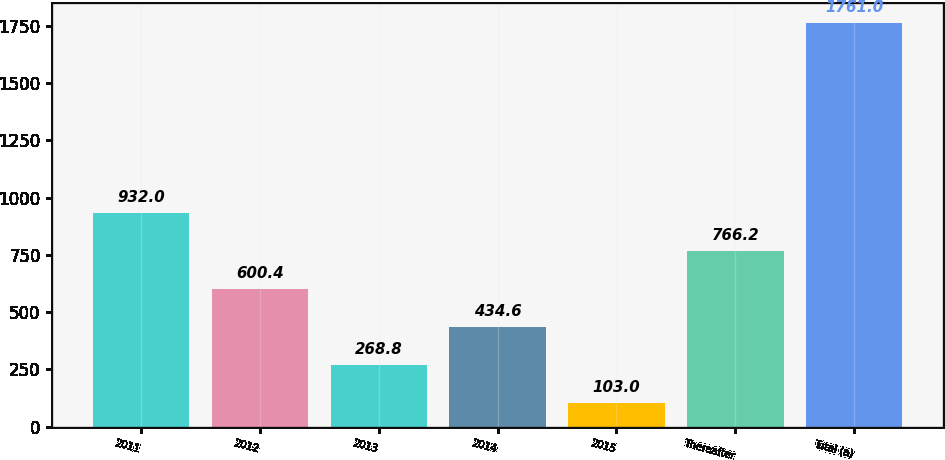Convert chart to OTSL. <chart><loc_0><loc_0><loc_500><loc_500><bar_chart><fcel>2011<fcel>2012<fcel>2013<fcel>2014<fcel>2015<fcel>Thereafter<fcel>Total (a)<nl><fcel>932<fcel>600.4<fcel>268.8<fcel>434.6<fcel>103<fcel>766.2<fcel>1761<nl></chart> 